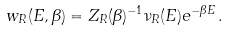<formula> <loc_0><loc_0><loc_500><loc_500>w _ { R } ( E , \beta ) = Z _ { R } ( \beta ) ^ { - 1 } \nu _ { R } ( E ) e ^ { - \beta E } \, .</formula> 